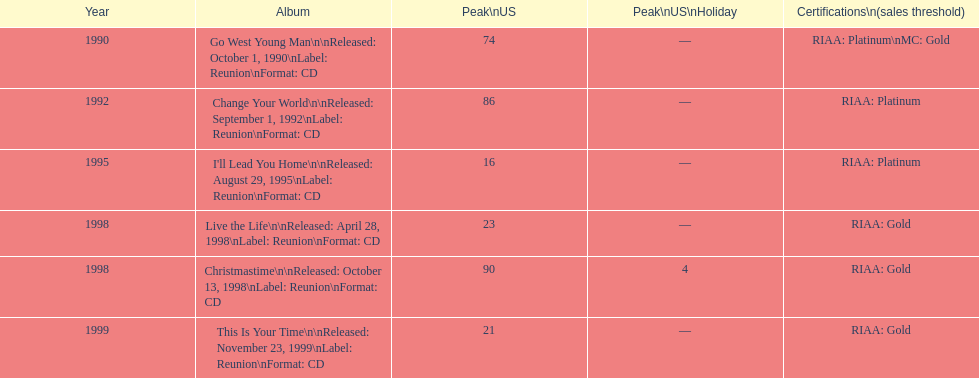Which is the most ancient year listed? 1990. 